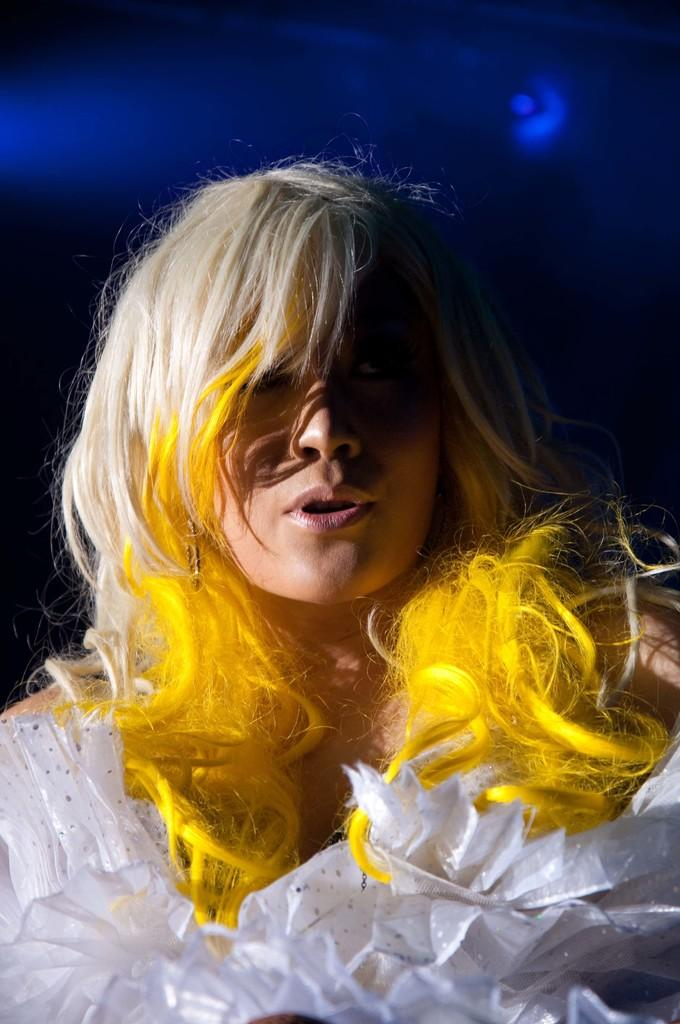Who is the main subject in the image? There is a woman in the image. What is the woman wearing? The woman is wearing clothes and earrings. What can be seen in the background of the image? The background of the image is dark, and blue lights are present. How does the woman attempt to join the cable in the image? There is no cable present in the image, so the woman cannot attempt to join it. 